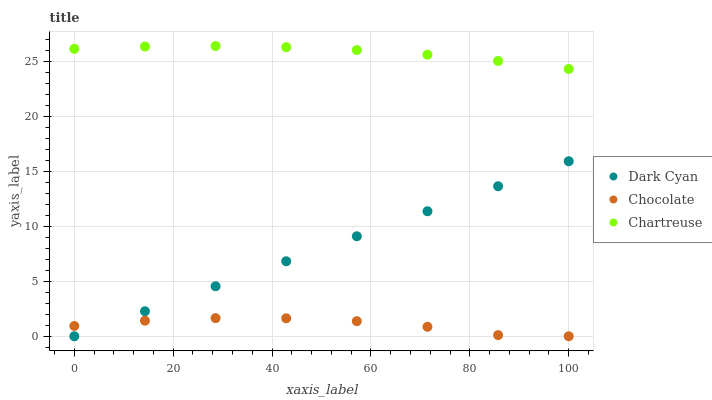Does Chocolate have the minimum area under the curve?
Answer yes or no. Yes. Does Chartreuse have the maximum area under the curve?
Answer yes or no. Yes. Does Chartreuse have the minimum area under the curve?
Answer yes or no. No. Does Chocolate have the maximum area under the curve?
Answer yes or no. No. Is Dark Cyan the smoothest?
Answer yes or no. Yes. Is Chocolate the roughest?
Answer yes or no. Yes. Is Chartreuse the smoothest?
Answer yes or no. No. Is Chartreuse the roughest?
Answer yes or no. No. Does Dark Cyan have the lowest value?
Answer yes or no. Yes. Does Chartreuse have the lowest value?
Answer yes or no. No. Does Chartreuse have the highest value?
Answer yes or no. Yes. Does Chocolate have the highest value?
Answer yes or no. No. Is Dark Cyan less than Chartreuse?
Answer yes or no. Yes. Is Chartreuse greater than Chocolate?
Answer yes or no. Yes. Does Chocolate intersect Dark Cyan?
Answer yes or no. Yes. Is Chocolate less than Dark Cyan?
Answer yes or no. No. Is Chocolate greater than Dark Cyan?
Answer yes or no. No. Does Dark Cyan intersect Chartreuse?
Answer yes or no. No. 